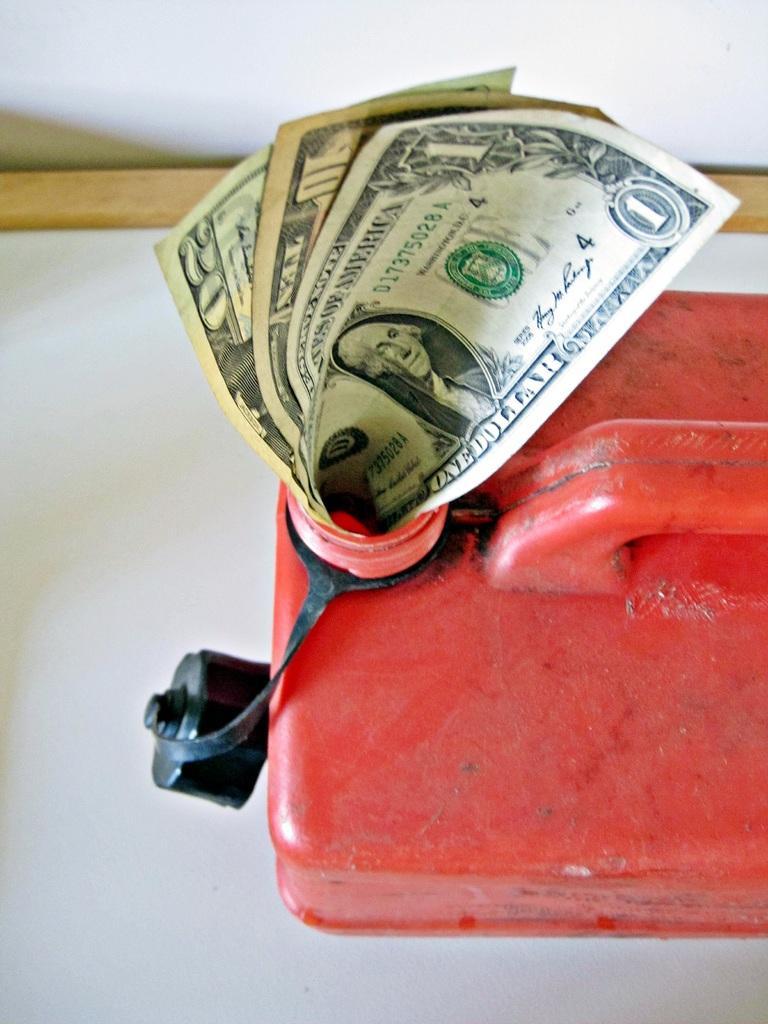Describe this image in one or two sentences. In this image in the front there is a can which is red in colour and in the can there are papers with some text and images and numbers on it and there is a black colour lid attached to the can which is on the surface which is white in colour. 